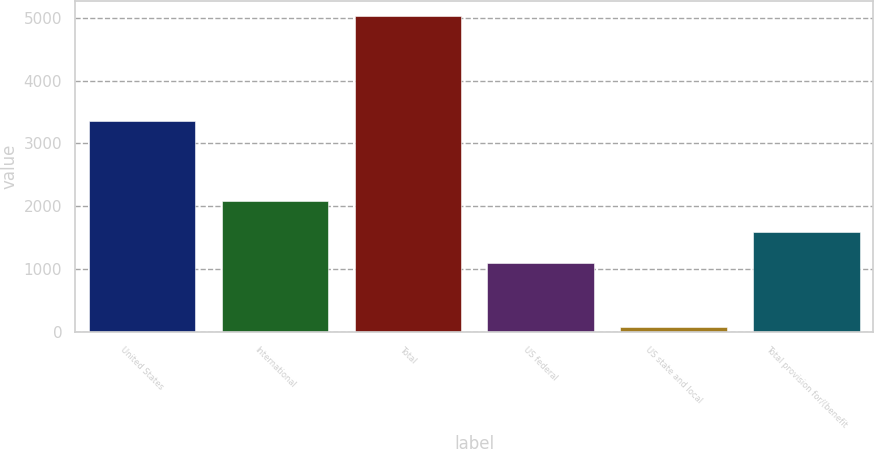Convert chart to OTSL. <chart><loc_0><loc_0><loc_500><loc_500><bar_chart><fcel>United States<fcel>International<fcel>Total<fcel>US federal<fcel>US state and local<fcel>Total provision for/(benefit<nl><fcel>3358<fcel>2084.4<fcel>5023<fcel>1095<fcel>76<fcel>1589.7<nl></chart> 